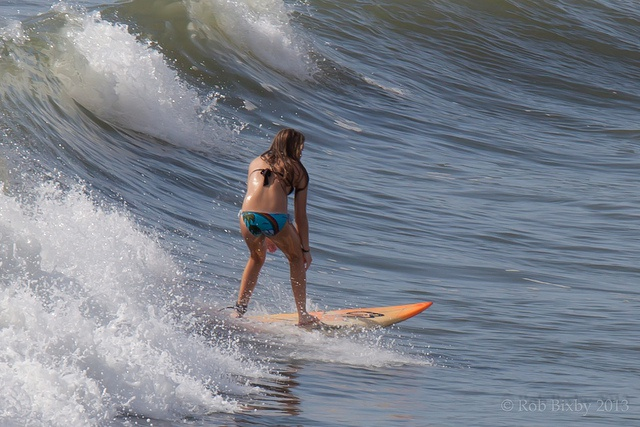Describe the objects in this image and their specific colors. I can see people in gray, maroon, black, and brown tones and surfboard in gray, tan, and darkgray tones in this image. 